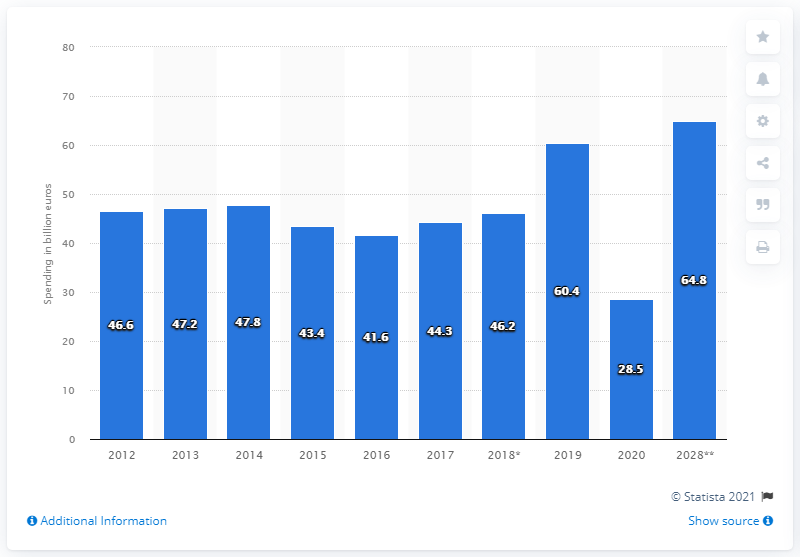Give some essential details in this illustration. According to forecasts, the annual value of visitor exports expected to reach in France by 2028 is 64.8 billion euros. The COVID-19 pandemic caused a significant portion of international tourists' expenditure, with 28.5% of their spending being lost due to the pandemic. 